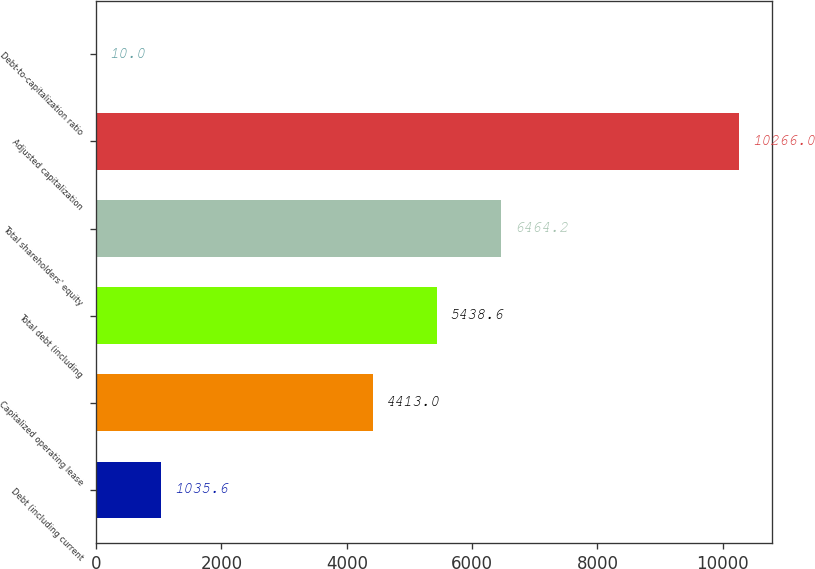<chart> <loc_0><loc_0><loc_500><loc_500><bar_chart><fcel>Debt (including current<fcel>Capitalized operating lease<fcel>Total debt (including<fcel>Total shareholders' equity<fcel>Adjusted capitalization<fcel>Debt-to-capitalization ratio<nl><fcel>1035.6<fcel>4413<fcel>5438.6<fcel>6464.2<fcel>10266<fcel>10<nl></chart> 